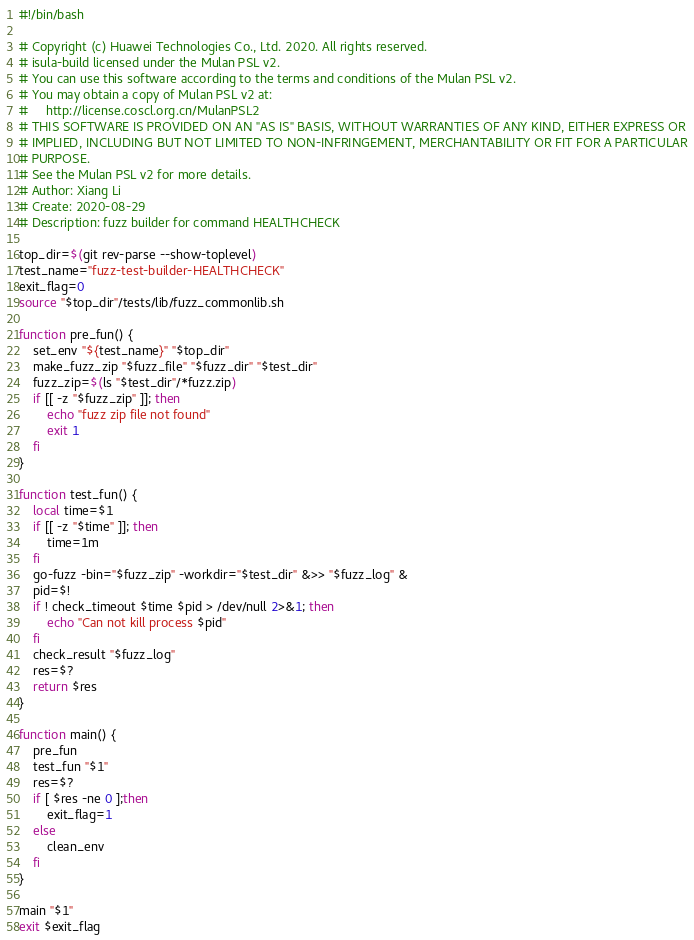Convert code to text. <code><loc_0><loc_0><loc_500><loc_500><_Bash_>#!/bin/bash

# Copyright (c) Huawei Technologies Co., Ltd. 2020. All rights reserved.
# isula-build licensed under the Mulan PSL v2.
# You can use this software according to the terms and conditions of the Mulan PSL v2.
# You may obtain a copy of Mulan PSL v2 at:
#     http://license.coscl.org.cn/MulanPSL2
# THIS SOFTWARE IS PROVIDED ON AN "AS IS" BASIS, WITHOUT WARRANTIES OF ANY KIND, EITHER EXPRESS OR
# IMPLIED, INCLUDING BUT NOT LIMITED TO NON-INFRINGEMENT, MERCHANTABILITY OR FIT FOR A PARTICULAR
# PURPOSE.
# See the Mulan PSL v2 for more details.
# Author: Xiang Li
# Create: 2020-08-29
# Description: fuzz builder for command HEALTHCHECK

top_dir=$(git rev-parse --show-toplevel)
test_name="fuzz-test-builder-HEALTHCHECK"
exit_flag=0
source "$top_dir"/tests/lib/fuzz_commonlib.sh

function pre_fun() {
    set_env "${test_name}" "$top_dir"
    make_fuzz_zip "$fuzz_file" "$fuzz_dir" "$test_dir"
    fuzz_zip=$(ls "$test_dir"/*fuzz.zip)
    if [[ -z "$fuzz_zip" ]]; then
        echo "fuzz zip file not found"
        exit 1
    fi
}

function test_fun() {
    local time=$1
    if [[ -z "$time" ]]; then
        time=1m
    fi
    go-fuzz -bin="$fuzz_zip" -workdir="$test_dir" &>> "$fuzz_log" &
    pid=$!
    if ! check_timeout $time $pid > /dev/null 2>&1; then
        echo "Can not kill process $pid"
    fi
    check_result "$fuzz_log"
    res=$?
    return $res
}

function main() {
    pre_fun
    test_fun "$1"
    res=$?
    if [ $res -ne 0 ];then
        exit_flag=1
    else
        clean_env
    fi
}

main "$1"
exit $exit_flag
</code> 